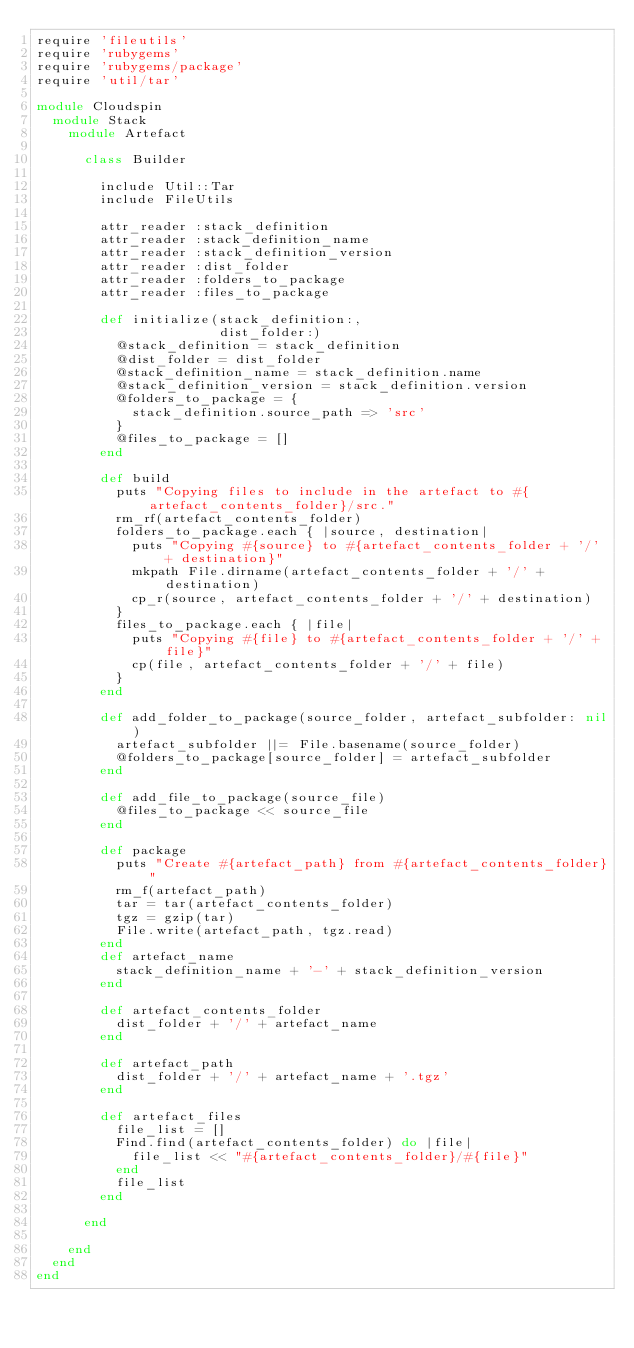<code> <loc_0><loc_0><loc_500><loc_500><_Ruby_>require 'fileutils'
require 'rubygems'
require 'rubygems/package'
require 'util/tar'

module Cloudspin
  module Stack
    module Artefact

      class Builder

        include Util::Tar
        include FileUtils

        attr_reader :stack_definition
        attr_reader :stack_definition_name
        attr_reader :stack_definition_version
        attr_reader :dist_folder
        attr_reader :folders_to_package
        attr_reader :files_to_package

        def initialize(stack_definition:,
                       dist_folder:)
          @stack_definition = stack_definition
          @dist_folder = dist_folder
          @stack_definition_name = stack_definition.name
          @stack_definition_version = stack_definition.version
          @folders_to_package = {
            stack_definition.source_path => 'src'
          }
          @files_to_package = []
        end

        def build
          puts "Copying files to include in the artefact to #{artefact_contents_folder}/src."
          rm_rf(artefact_contents_folder)
          folders_to_package.each { |source, destination|
            puts "Copying #{source} to #{artefact_contents_folder + '/' + destination}"
            mkpath File.dirname(artefact_contents_folder + '/' + destination)
            cp_r(source, artefact_contents_folder + '/' + destination)
          }
          files_to_package.each { |file|
            puts "Copying #{file} to #{artefact_contents_folder + '/' + file}"
            cp(file, artefact_contents_folder + '/' + file)
          }
        end

        def add_folder_to_package(source_folder, artefact_subfolder: nil)
          artefact_subfolder ||= File.basename(source_folder)
          @folders_to_package[source_folder] = artefact_subfolder
        end

        def add_file_to_package(source_file)
          @files_to_package << source_file
        end

        def package
          puts "Create #{artefact_path} from #{artefact_contents_folder}"
          rm_f(artefact_path)
          tar = tar(artefact_contents_folder)
          tgz = gzip(tar)
          File.write(artefact_path, tgz.read)
        end
        def artefact_name
          stack_definition_name + '-' + stack_definition_version
        end

        def artefact_contents_folder
          dist_folder + '/' + artefact_name
        end

        def artefact_path
          dist_folder + '/' + artefact_name + '.tgz'
        end

        def artefact_files
          file_list = []
          Find.find(artefact_contents_folder) do |file|
            file_list << "#{artefact_contents_folder}/#{file}"
          end
          file_list
        end

      end

    end
  end
end
</code> 